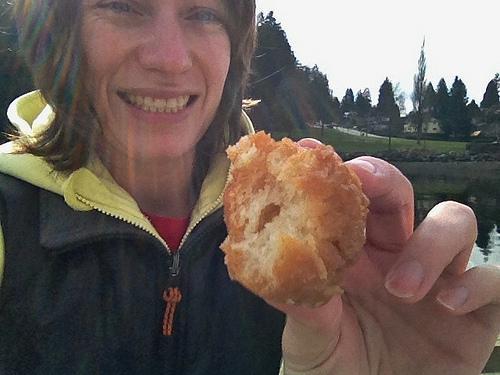How many people are in the picture?
Give a very brief answer. 1. 